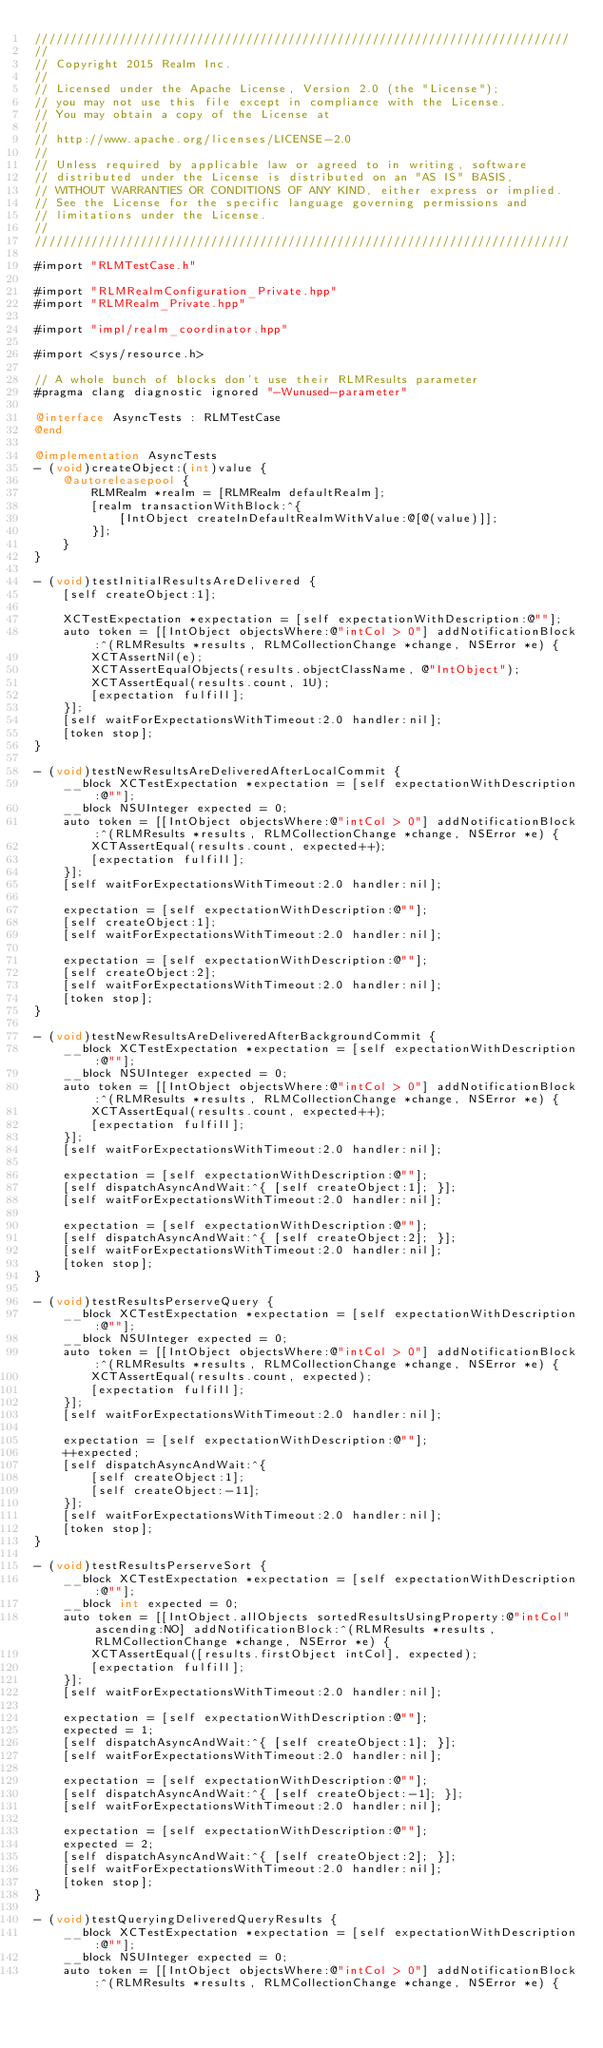<code> <loc_0><loc_0><loc_500><loc_500><_ObjectiveC_>////////////////////////////////////////////////////////////////////////////
//
// Copyright 2015 Realm Inc.
//
// Licensed under the Apache License, Version 2.0 (the "License");
// you may not use this file except in compliance with the License.
// You may obtain a copy of the License at
//
// http://www.apache.org/licenses/LICENSE-2.0
//
// Unless required by applicable law or agreed to in writing, software
// distributed under the License is distributed on an "AS IS" BASIS,
// WITHOUT WARRANTIES OR CONDITIONS OF ANY KIND, either express or implied.
// See the License for the specific language governing permissions and
// limitations under the License.
//
////////////////////////////////////////////////////////////////////////////

#import "RLMTestCase.h"

#import "RLMRealmConfiguration_Private.hpp"
#import "RLMRealm_Private.hpp"

#import "impl/realm_coordinator.hpp"

#import <sys/resource.h>

// A whole bunch of blocks don't use their RLMResults parameter
#pragma clang diagnostic ignored "-Wunused-parameter"

@interface AsyncTests : RLMTestCase
@end

@implementation AsyncTests
- (void)createObject:(int)value {
    @autoreleasepool {
        RLMRealm *realm = [RLMRealm defaultRealm];
        [realm transactionWithBlock:^{
            [IntObject createInDefaultRealmWithValue:@[@(value)]];
        }];
    }
}

- (void)testInitialResultsAreDelivered {
    [self createObject:1];

    XCTestExpectation *expectation = [self expectationWithDescription:@""];
    auto token = [[IntObject objectsWhere:@"intCol > 0"] addNotificationBlock:^(RLMResults *results, RLMCollectionChange *change, NSError *e) {
        XCTAssertNil(e);
        XCTAssertEqualObjects(results.objectClassName, @"IntObject");
        XCTAssertEqual(results.count, 1U);
        [expectation fulfill];
    }];
    [self waitForExpectationsWithTimeout:2.0 handler:nil];
    [token stop];
}

- (void)testNewResultsAreDeliveredAfterLocalCommit {
    __block XCTestExpectation *expectation = [self expectationWithDescription:@""];
    __block NSUInteger expected = 0;
    auto token = [[IntObject objectsWhere:@"intCol > 0"] addNotificationBlock:^(RLMResults *results, RLMCollectionChange *change, NSError *e) {
        XCTAssertEqual(results.count, expected++);
        [expectation fulfill];
    }];
    [self waitForExpectationsWithTimeout:2.0 handler:nil];

    expectation = [self expectationWithDescription:@""];
    [self createObject:1];
    [self waitForExpectationsWithTimeout:2.0 handler:nil];

    expectation = [self expectationWithDescription:@""];
    [self createObject:2];
    [self waitForExpectationsWithTimeout:2.0 handler:nil];
    [token stop];
}

- (void)testNewResultsAreDeliveredAfterBackgroundCommit {
    __block XCTestExpectation *expectation = [self expectationWithDescription:@""];
    __block NSUInteger expected = 0;
    auto token = [[IntObject objectsWhere:@"intCol > 0"] addNotificationBlock:^(RLMResults *results, RLMCollectionChange *change, NSError *e) {
        XCTAssertEqual(results.count, expected++);
        [expectation fulfill];
    }];
    [self waitForExpectationsWithTimeout:2.0 handler:nil];

    expectation = [self expectationWithDescription:@""];
    [self dispatchAsyncAndWait:^{ [self createObject:1]; }];
    [self waitForExpectationsWithTimeout:2.0 handler:nil];

    expectation = [self expectationWithDescription:@""];
    [self dispatchAsyncAndWait:^{ [self createObject:2]; }];
    [self waitForExpectationsWithTimeout:2.0 handler:nil];
    [token stop];
}

- (void)testResultsPerserveQuery {
    __block XCTestExpectation *expectation = [self expectationWithDescription:@""];
    __block NSUInteger expected = 0;
    auto token = [[IntObject objectsWhere:@"intCol > 0"] addNotificationBlock:^(RLMResults *results, RLMCollectionChange *change, NSError *e) {
        XCTAssertEqual(results.count, expected);
        [expectation fulfill];
    }];
    [self waitForExpectationsWithTimeout:2.0 handler:nil];

    expectation = [self expectationWithDescription:@""];
    ++expected;
    [self dispatchAsyncAndWait:^{
        [self createObject:1];
        [self createObject:-11];
    }];
    [self waitForExpectationsWithTimeout:2.0 handler:nil];
    [token stop];
}

- (void)testResultsPerserveSort {
    __block XCTestExpectation *expectation = [self expectationWithDescription:@""];
    __block int expected = 0;
    auto token = [[IntObject.allObjects sortedResultsUsingProperty:@"intCol" ascending:NO] addNotificationBlock:^(RLMResults *results, RLMCollectionChange *change, NSError *e) {
        XCTAssertEqual([results.firstObject intCol], expected);
        [expectation fulfill];
    }];
    [self waitForExpectationsWithTimeout:2.0 handler:nil];

    expectation = [self expectationWithDescription:@""];
    expected = 1;
    [self dispatchAsyncAndWait:^{ [self createObject:1]; }];
    [self waitForExpectationsWithTimeout:2.0 handler:nil];

    expectation = [self expectationWithDescription:@""];
    [self dispatchAsyncAndWait:^{ [self createObject:-1]; }];
    [self waitForExpectationsWithTimeout:2.0 handler:nil];

    expectation = [self expectationWithDescription:@""];
    expected = 2;
    [self dispatchAsyncAndWait:^{ [self createObject:2]; }];
    [self waitForExpectationsWithTimeout:2.0 handler:nil];
    [token stop];
}

- (void)testQueryingDeliveredQueryResults {
    __block XCTestExpectation *expectation = [self expectationWithDescription:@""];
    __block NSUInteger expected = 0;
    auto token = [[IntObject objectsWhere:@"intCol > 0"] addNotificationBlock:^(RLMResults *results, RLMCollectionChange *change, NSError *e) {</code> 